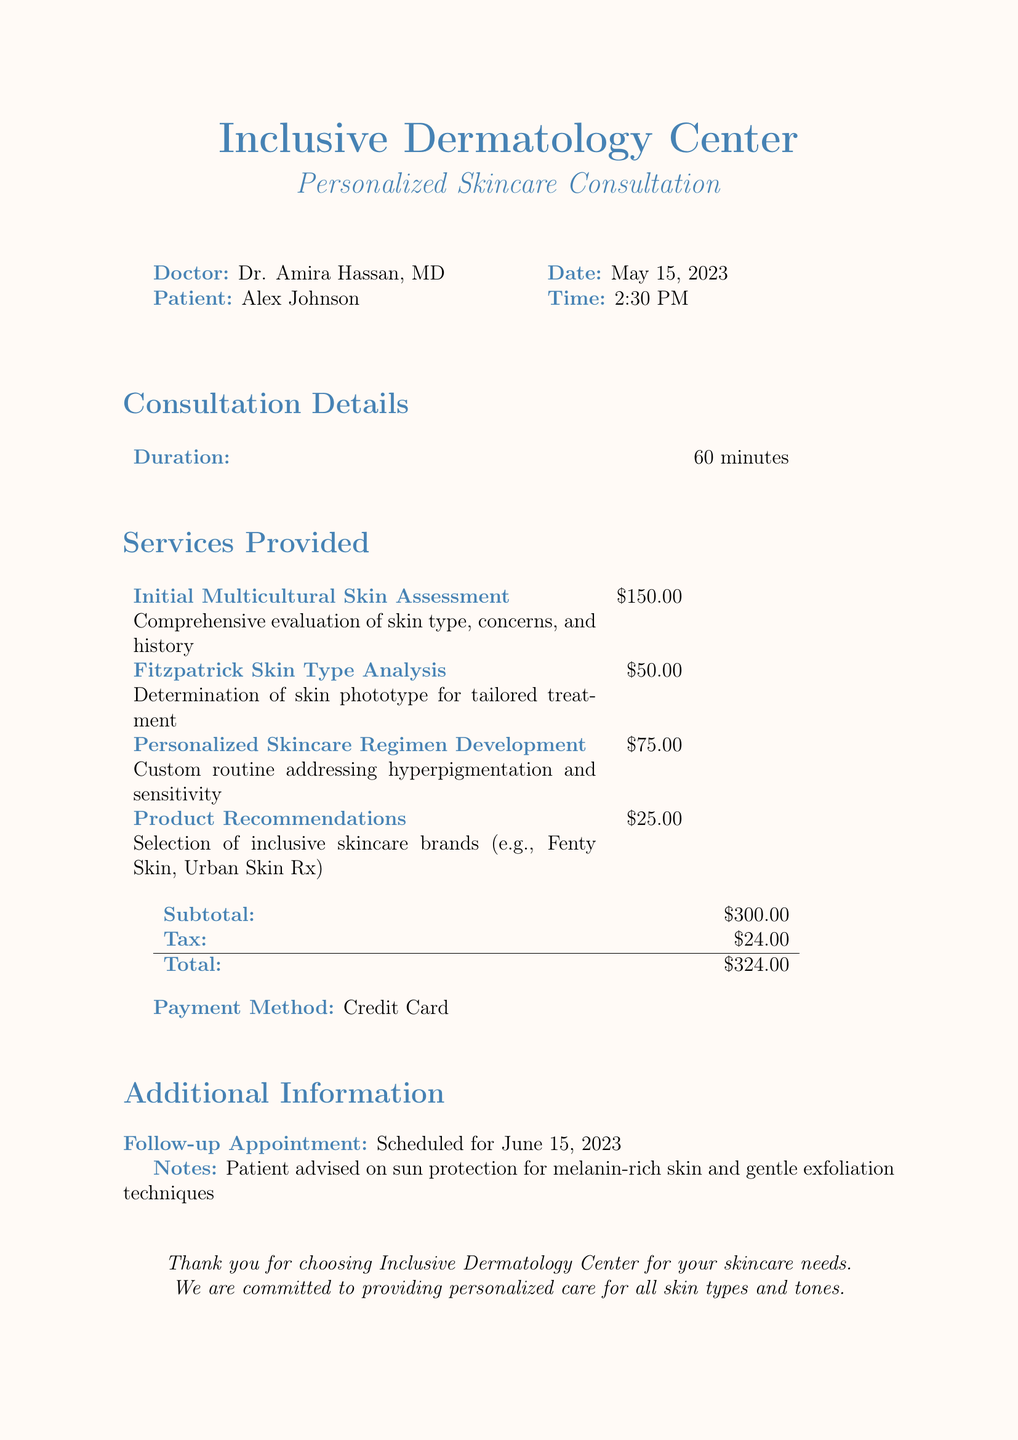What is the patient's name? The patient's name is listed in the document under the "Patient" section.
Answer: Alex Johnson What is the date of the consultation? The date of the consultation is provided at the beginning of the document.
Answer: May 15, 2023 How long was the consultation? The duration of the consultation is indicated in the "Consultation Details" section.
Answer: 60 minutes What is the price of the Initial Multicultural Skin Assessment? The cost for this service is listed in the "Services Provided" section of the document.
Answer: $150.00 How much is the total bill? The total amount is calculated by adding the subtotal and tax in the document.
Answer: $324.00 Who is the doctor conducting the consultation? The doctor's name is specified in the document under the "Doctor" section.
Answer: Dr. Amira Hassan, MD What product brands were recommended? The document lists examples of brands in the "Product Recommendations" service.
Answer: Fenty Skin, Urban Skin Rx What follow-up appointment date is scheduled? The follow-up appointment date is provided in the "Additional Information" section.
Answer: June 15, 2023 What payment method was used? The payment method is stated at the end of the bill.
Answer: Credit Card 